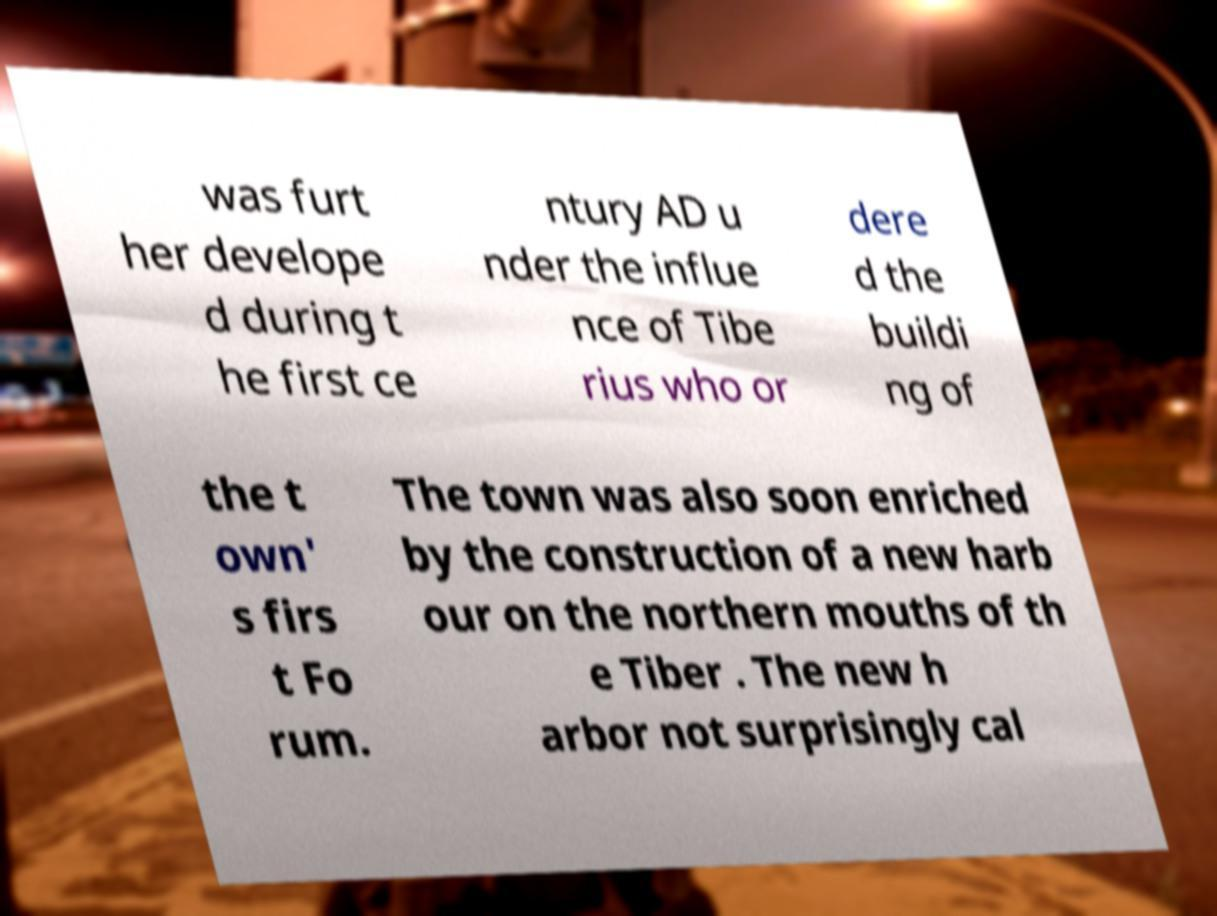Could you assist in decoding the text presented in this image and type it out clearly? was furt her develope d during t he first ce ntury AD u nder the influe nce of Tibe rius who or dere d the buildi ng of the t own' s firs t Fo rum. The town was also soon enriched by the construction of a new harb our on the northern mouths of th e Tiber . The new h arbor not surprisingly cal 